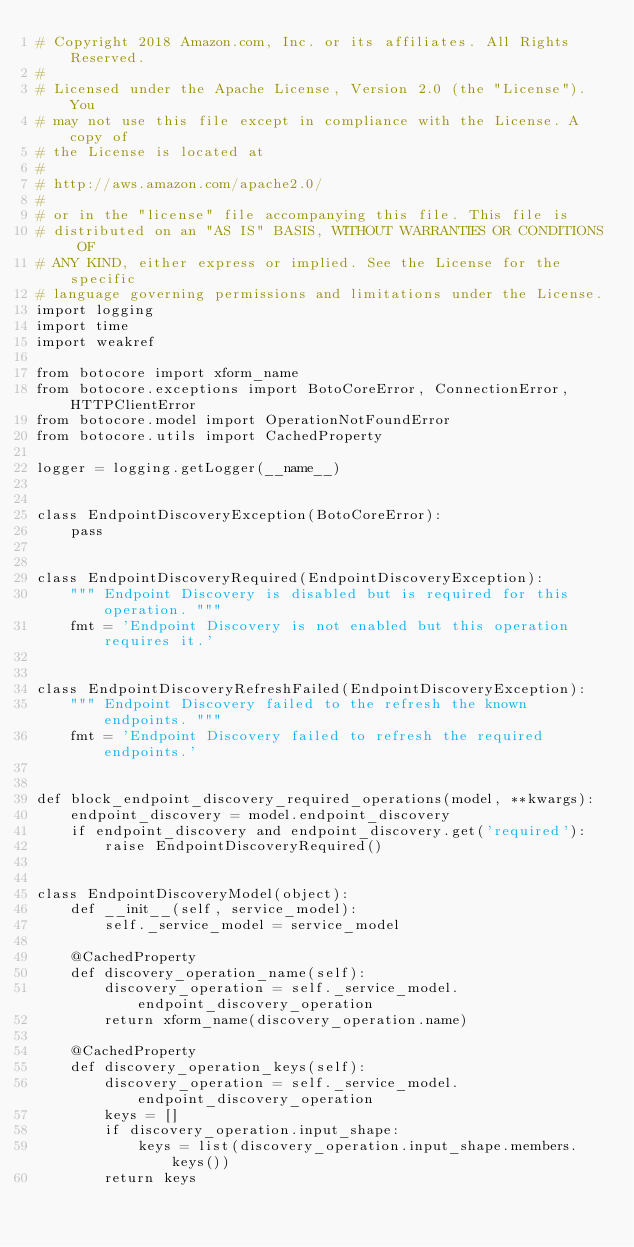Convert code to text. <code><loc_0><loc_0><loc_500><loc_500><_Python_># Copyright 2018 Amazon.com, Inc. or its affiliates. All Rights Reserved.
#
# Licensed under the Apache License, Version 2.0 (the "License"). You
# may not use this file except in compliance with the License. A copy of
# the License is located at
#
# http://aws.amazon.com/apache2.0/
#
# or in the "license" file accompanying this file. This file is
# distributed on an "AS IS" BASIS, WITHOUT WARRANTIES OR CONDITIONS OF
# ANY KIND, either express or implied. See the License for the specific
# language governing permissions and limitations under the License.
import logging
import time
import weakref

from botocore import xform_name
from botocore.exceptions import BotoCoreError, ConnectionError, HTTPClientError
from botocore.model import OperationNotFoundError
from botocore.utils import CachedProperty

logger = logging.getLogger(__name__)


class EndpointDiscoveryException(BotoCoreError):
    pass


class EndpointDiscoveryRequired(EndpointDiscoveryException):
    """ Endpoint Discovery is disabled but is required for this operation. """
    fmt = 'Endpoint Discovery is not enabled but this operation requires it.'


class EndpointDiscoveryRefreshFailed(EndpointDiscoveryException):
    """ Endpoint Discovery failed to the refresh the known endpoints. """
    fmt = 'Endpoint Discovery failed to refresh the required endpoints.'


def block_endpoint_discovery_required_operations(model, **kwargs):
    endpoint_discovery = model.endpoint_discovery
    if endpoint_discovery and endpoint_discovery.get('required'):
        raise EndpointDiscoveryRequired()


class EndpointDiscoveryModel(object):
    def __init__(self, service_model):
        self._service_model = service_model

    @CachedProperty
    def discovery_operation_name(self):
        discovery_operation = self._service_model.endpoint_discovery_operation
        return xform_name(discovery_operation.name)

    @CachedProperty
    def discovery_operation_keys(self):
        discovery_operation = self._service_model.endpoint_discovery_operation
        keys = []
        if discovery_operation.input_shape:
            keys = list(discovery_operation.input_shape.members.keys())
        return keys
</code> 